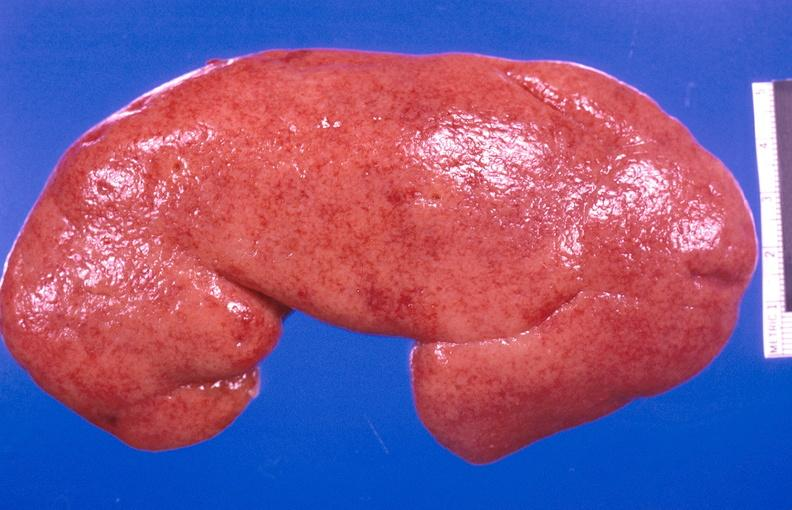what does this image show?
Answer the question using a single word or phrase. Kidney aspergillosis 